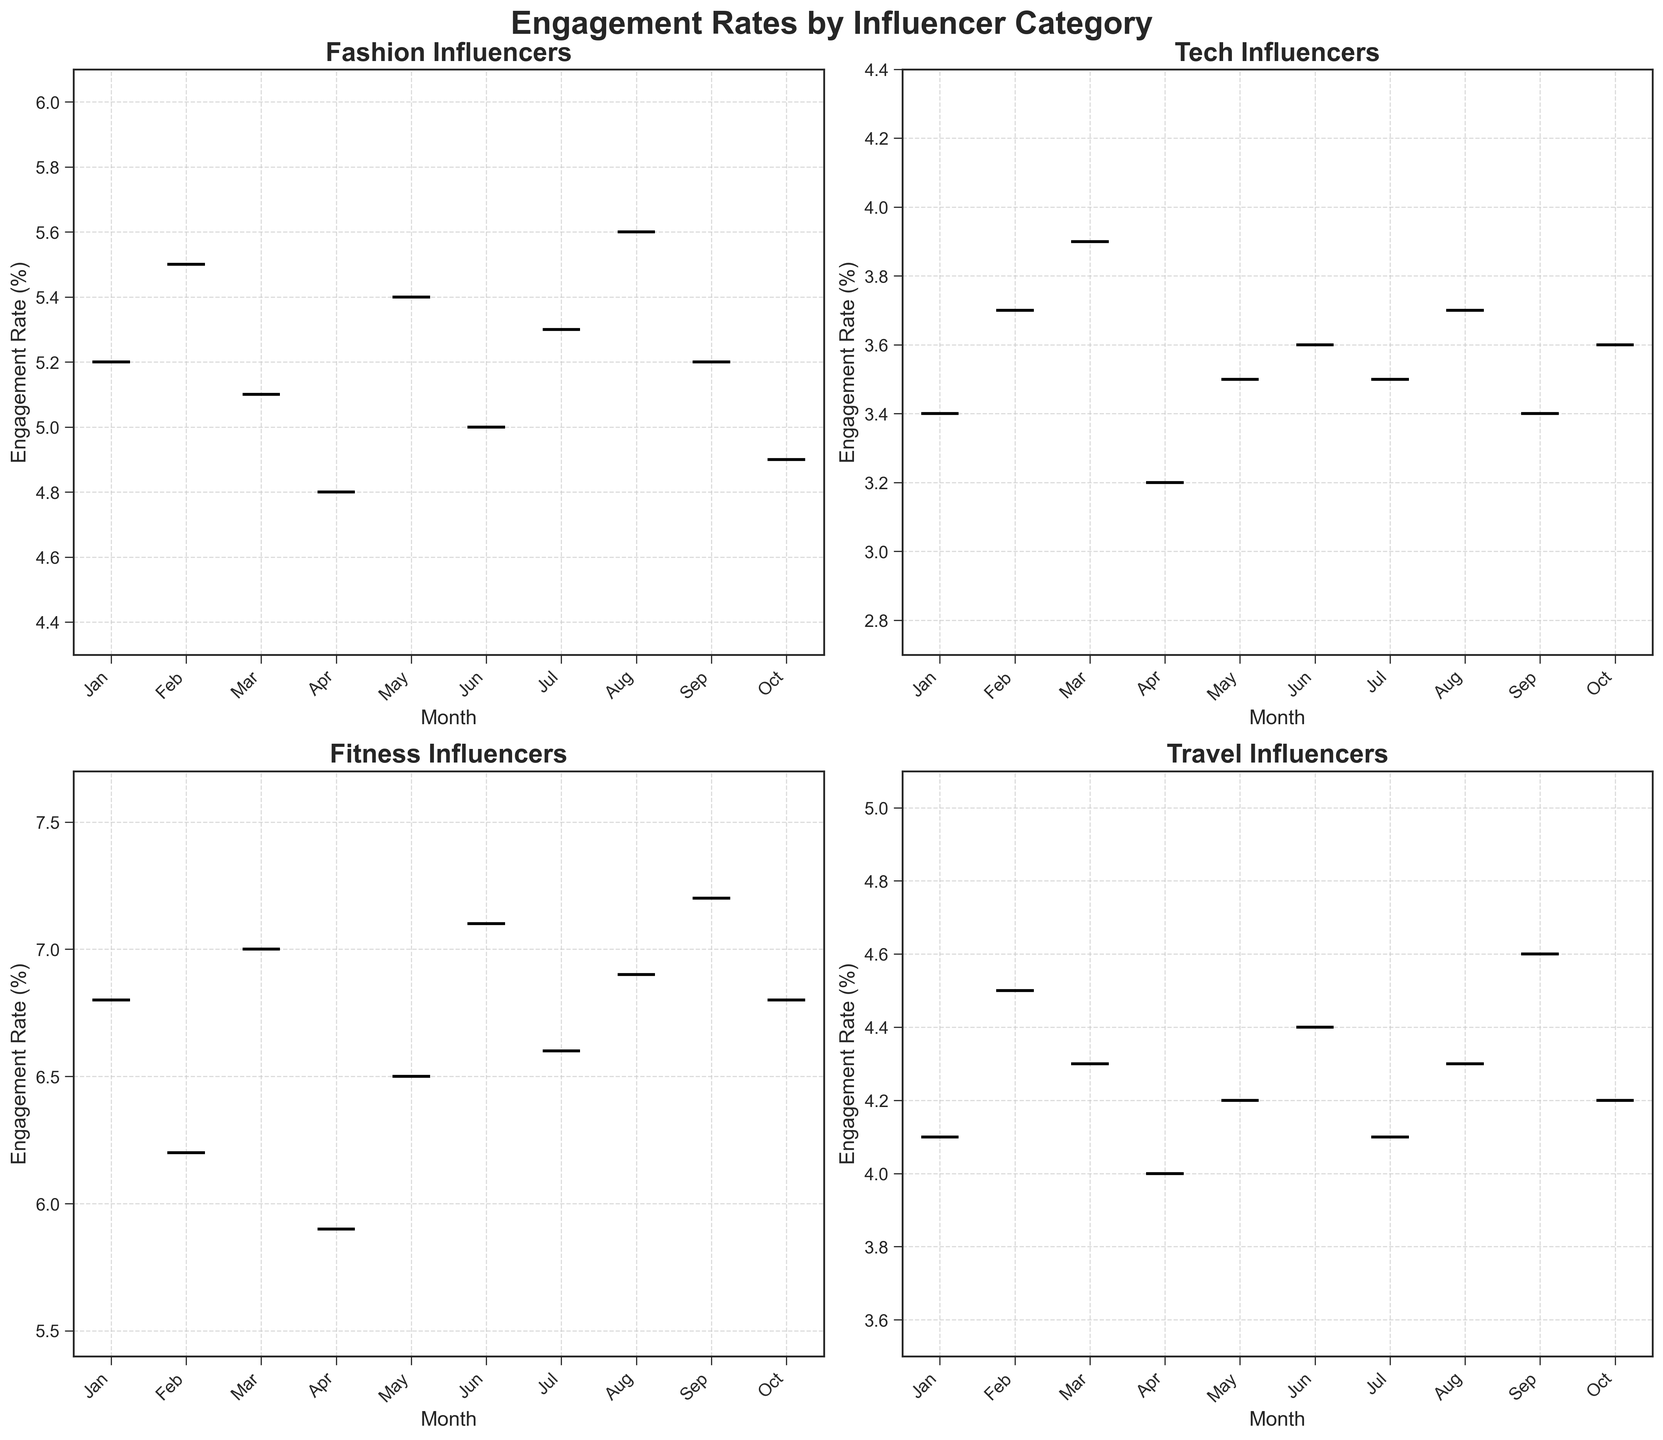What is the title of the entire figure? The title of the entire figure is located at the top center and is bolded, reading "Engagement Rates by Influencer Category".
Answer: Engagement Rates by Influencer Category Which influencer category has the highest median engagement rate in January? By looking at the box plots for January within each subplot, the Fitness category has the highest median engagement rate as its box plot is positioned higher than those of other categories.
Answer: Fitness Compare the median engagement rates between Fashion and Tech influencers over the months. Which one sees more variation? To determine this, observe the variations in the medians, represented by the horizontal lines inside the box plots, in the Fashion and Tech charts. Fashion shows larger variations, notably oscillating between approximately 4.8% and 5.6%, whereas Tech remains relatively stable, ranging from around 3.2% to 3.9%.
Answer: Fashion Which month exhibited the lowest engagement rate for Travel influencers? Look for the minimum values in the Travel category subplot. The lowest box plot is in April, where the whisker extends down to around 4.0%.
Answer: April What can be said about the stability of engagement rates for the Tech category? The box plots for the Tech category show relatively small boxes and whiskers, indicating that engagement rates are consistent and stable across months, generally between 3.2% and 3.9%.
Answer: Stable and consistent What trend can be observed in the engagement rates for the Fitness category from January to October? Examine how the median lines inside the box plots shift over time for the Fitness category. Fitness generally maintains high engagement rates, frequently around 6.5% to 7.2%, indicating consistently strong engagement.
Answer: Consistently high Is there any month where all categories exhibited their highest engagement rates simultaneously? Compare the highest points (tops of the whiskers) in each subplot for all months. No month features the highest engagement rates for all categories simultaneously; their peaks occur in different months.
Answer: No Which influencer category showed the most significant drop in engagement rate in any single month? Notice abrupt changes in median lines or overall box plot positions. The Fashion category exhibited a notable drop in April from around 5.1% to 4.8%, visible by a downward shift in its box plot.
Answer: Fashion (from March to April) For which months are the engagement rates of Travel influencers above 4.0%? Look at the Travel subplot, identifying months where the medians (horizontal lines) and most of the boxes are above 4.0%. Months meeting this criterion are February, March, May, June, August, September, and October.
Answer: February, March, May, June, August, September, October 